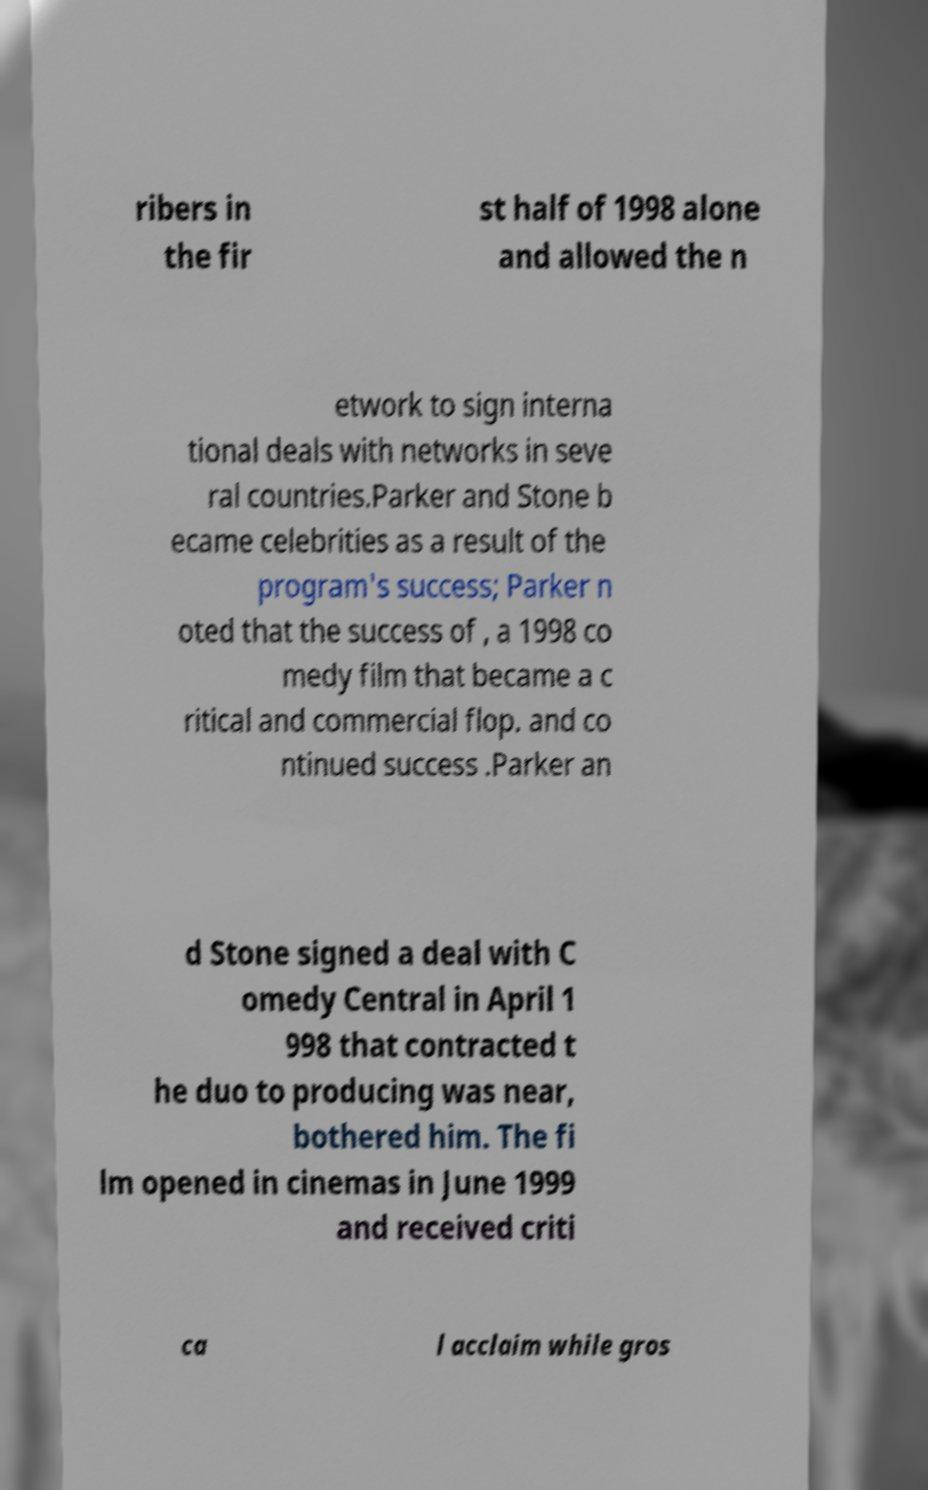Please identify and transcribe the text found in this image. ribers in the fir st half of 1998 alone and allowed the n etwork to sign interna tional deals with networks in seve ral countries.Parker and Stone b ecame celebrities as a result of the program's success; Parker n oted that the success of , a 1998 co medy film that became a c ritical and commercial flop. and co ntinued success .Parker an d Stone signed a deal with C omedy Central in April 1 998 that contracted t he duo to producing was near, bothered him. The fi lm opened in cinemas in June 1999 and received criti ca l acclaim while gros 